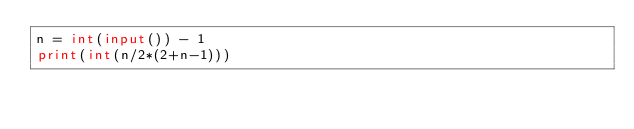<code> <loc_0><loc_0><loc_500><loc_500><_Python_>n = int(input()) - 1
print(int(n/2*(2+n-1)))</code> 